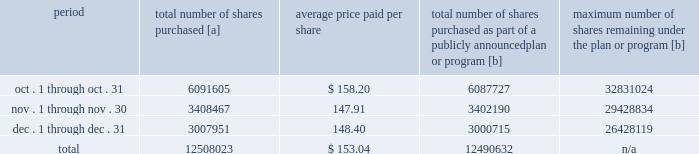Purchases of equity securities 2013 during 2018 , we repurchased 57669746 shares of our common stock at an average price of $ 143.70 .
The table presents common stock repurchases during each month for the fourth quarter of 2018 : period total number of shares purchased [a] average price paid per share total number of shares purchased as part of a publicly announced plan or program [b] maximum number of shares remaining under the plan or program [b] .
[a] total number of shares purchased during the quarter includes approximately 17391 shares delivered or attested to upc by employees to pay stock option exercise prices , satisfy excess tax withholding obligations for stock option exercises or vesting of retention units , and pay withholding obligations for vesting of retention shares .
[b] effective january 1 , 2017 , our board of directors authorized the repurchase of up to 120 million shares of our common stock by december 31 , 2020 .
These repurchases may be made on the open market or through other transactions .
Our management has sole discretion with respect to determining the timing and amount of these transactions. .
What was the total cost of share repurchases , in millions , during 2018? 
Computations: ((57669746 / 1000000) * 143.70)
Answer: 8287.1425. 